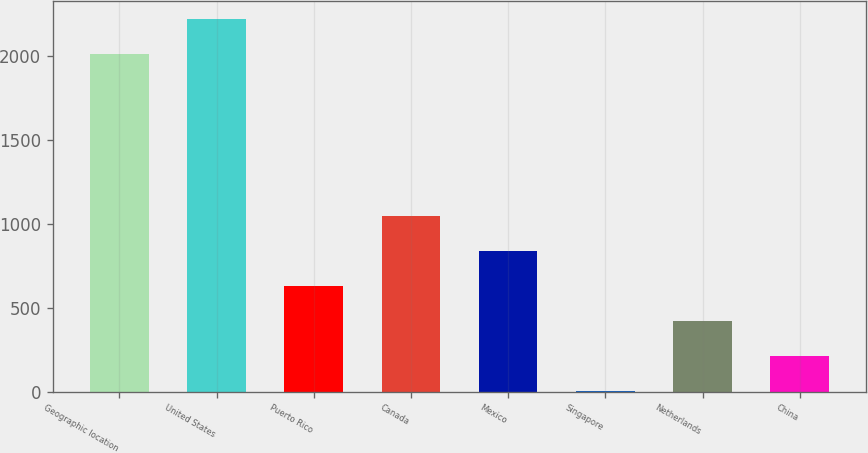<chart> <loc_0><loc_0><loc_500><loc_500><bar_chart><fcel>Geographic location<fcel>United States<fcel>Puerto Rico<fcel>Canada<fcel>Mexico<fcel>Singapore<fcel>Netherlands<fcel>China<nl><fcel>2008<fcel>2217.6<fcel>629.8<fcel>1049<fcel>839.4<fcel>1<fcel>420.2<fcel>210.6<nl></chart> 